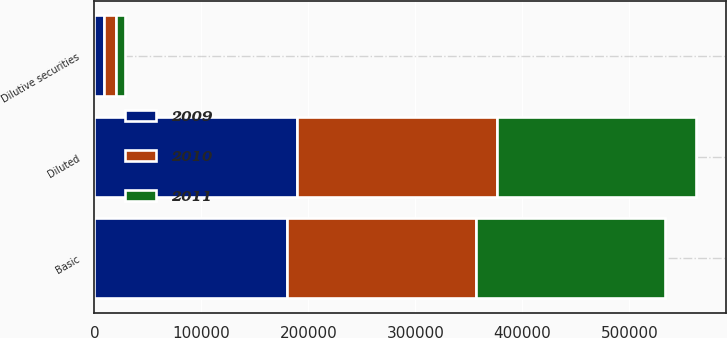Convert chart to OTSL. <chart><loc_0><loc_0><loc_500><loc_500><stacked_bar_chart><ecel><fcel>Basic<fcel>Dilutive securities<fcel>Diluted<nl><fcel>2010<fcel>176212<fcel>10462<fcel>186674<nl><fcel>2011<fcel>177028<fcel>9014<fcel>186042<nl><fcel>2009<fcel>179934<fcel>9352<fcel>189286<nl></chart> 